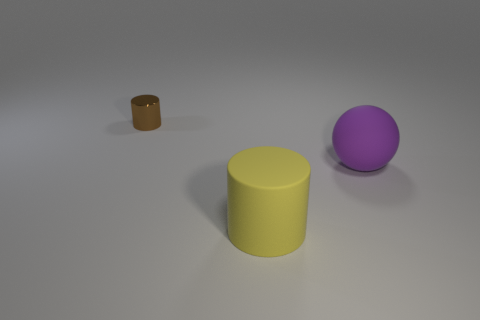Are there any other things that are the same size as the metal object?
Give a very brief answer. No. What is the color of the other rubber object that is the same size as the yellow rubber object?
Make the answer very short. Purple. Is there a brown thing of the same shape as the large yellow rubber thing?
Ensure brevity in your answer.  Yes. What material is the cylinder behind the big object behind the cylinder right of the tiny metallic cylinder?
Make the answer very short. Metal. What number of other objects are there of the same size as the yellow cylinder?
Offer a very short reply. 1. What color is the big ball?
Give a very brief answer. Purple. How many metal things are either brown spheres or yellow cylinders?
Keep it short and to the point. 0. Is there anything else that is made of the same material as the purple sphere?
Provide a succinct answer. Yes. There is a object that is behind the large rubber thing on the right side of the cylinder that is on the right side of the brown object; how big is it?
Ensure brevity in your answer.  Small. What is the size of the object that is behind the yellow thing and in front of the tiny metallic thing?
Your answer should be very brief. Large. 